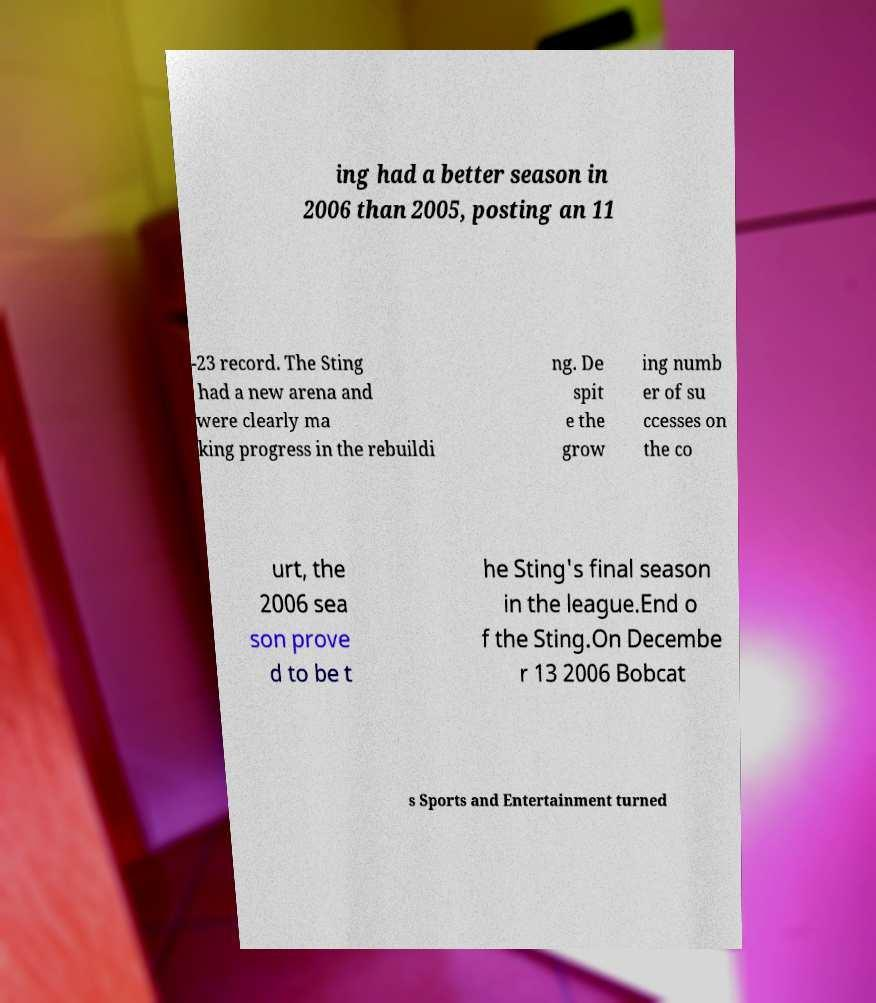What messages or text are displayed in this image? I need them in a readable, typed format. ing had a better season in 2006 than 2005, posting an 11 -23 record. The Sting had a new arena and were clearly ma king progress in the rebuildi ng. De spit e the grow ing numb er of su ccesses on the co urt, the 2006 sea son prove d to be t he Sting's final season in the league.End o f the Sting.On Decembe r 13 2006 Bobcat s Sports and Entertainment turned 